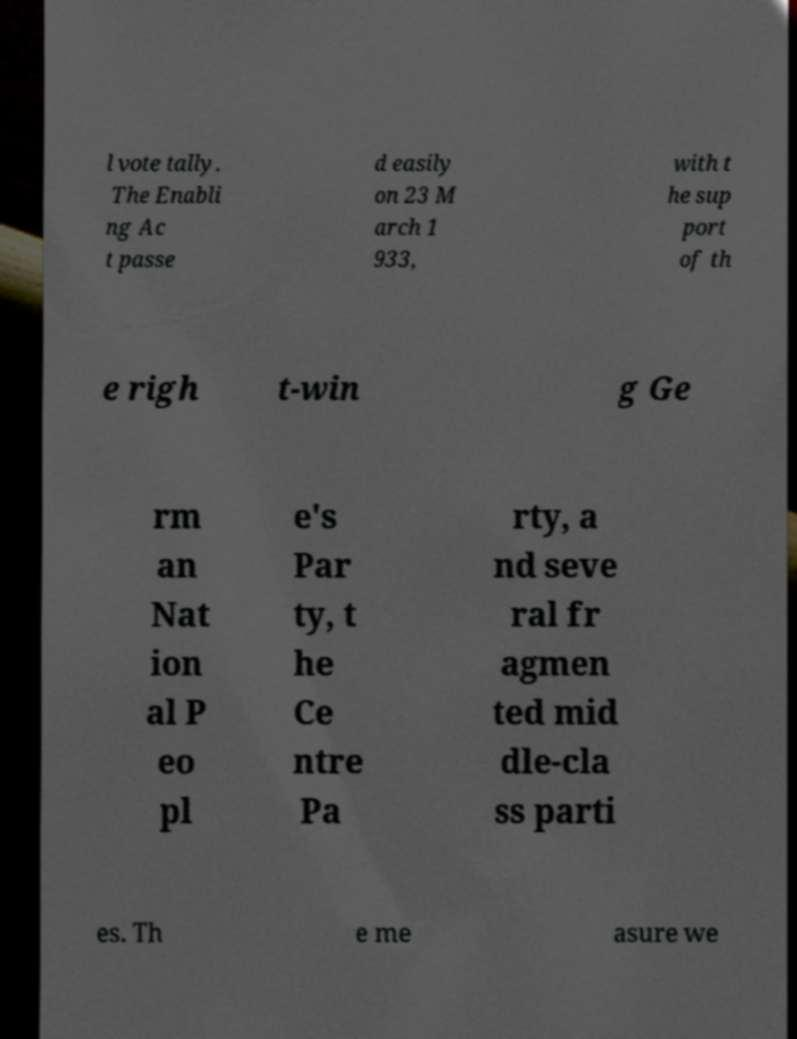I need the written content from this picture converted into text. Can you do that? l vote tally. The Enabli ng Ac t passe d easily on 23 M arch 1 933, with t he sup port of th e righ t-win g Ge rm an Nat ion al P eo pl e's Par ty, t he Ce ntre Pa rty, a nd seve ral fr agmen ted mid dle-cla ss parti es. Th e me asure we 